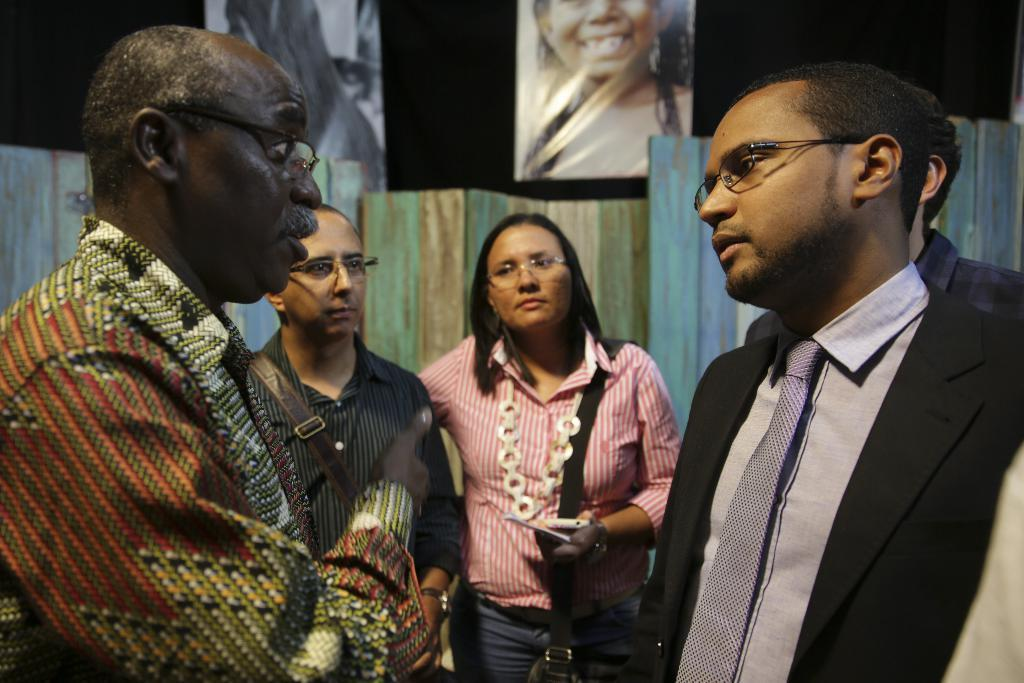What are the people in the image doing? The people in the image are standing and holding a phone and a paper. What can be seen in the hands of the people? The people are holding a phone and a paper. What is visible in the background of the image? There is a wooden wall in the background of the image, and the background is dark. What is attached to the wooden wall? There are posters attached to the wall. What type of juice is being served in the image? There is no juice present in the image. What thrilling activity are the people participating in? There is no thrilling activity depicted in the image; the people are simply standing and holding a phone and a paper. 